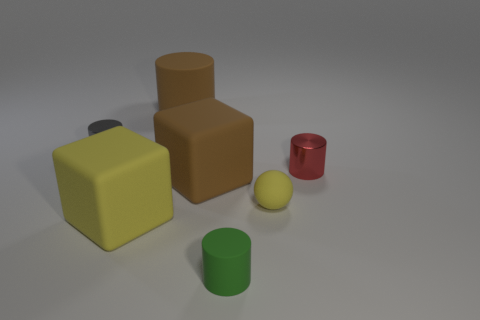Subtract all tiny cylinders. How many cylinders are left? 1 Subtract all brown cylinders. How many cylinders are left? 3 Add 1 big gray metallic blocks. How many objects exist? 8 Subtract 1 blocks. How many blocks are left? 1 Subtract all spheres. How many objects are left? 6 Subtract all red cylinders. Subtract all cyan balls. How many cylinders are left? 3 Subtract all tiny red shiny cylinders. Subtract all red things. How many objects are left? 5 Add 4 green cylinders. How many green cylinders are left? 5 Add 1 tiny green cylinders. How many tiny green cylinders exist? 2 Subtract 1 yellow blocks. How many objects are left? 6 